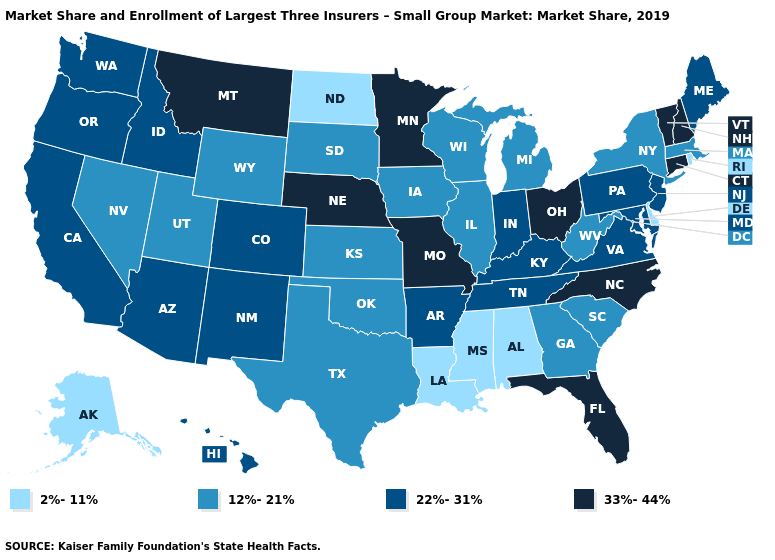Does the map have missing data?
Short answer required. No. What is the highest value in the USA?
Give a very brief answer. 33%-44%. What is the value of New York?
Keep it brief. 12%-21%. What is the value of Ohio?
Answer briefly. 33%-44%. Name the states that have a value in the range 2%-11%?
Keep it brief. Alabama, Alaska, Delaware, Louisiana, Mississippi, North Dakota, Rhode Island. Name the states that have a value in the range 33%-44%?
Answer briefly. Connecticut, Florida, Minnesota, Missouri, Montana, Nebraska, New Hampshire, North Carolina, Ohio, Vermont. What is the value of Iowa?
Give a very brief answer. 12%-21%. Does Alaska have the lowest value in the West?
Short answer required. Yes. How many symbols are there in the legend?
Short answer required. 4. Which states have the lowest value in the USA?
Quick response, please. Alabama, Alaska, Delaware, Louisiana, Mississippi, North Dakota, Rhode Island. Name the states that have a value in the range 22%-31%?
Answer briefly. Arizona, Arkansas, California, Colorado, Hawaii, Idaho, Indiana, Kentucky, Maine, Maryland, New Jersey, New Mexico, Oregon, Pennsylvania, Tennessee, Virginia, Washington. Among the states that border Oregon , which have the lowest value?
Concise answer only. Nevada. Does Missouri have the highest value in the USA?
Be succinct. Yes. What is the value of New York?
Write a very short answer. 12%-21%. How many symbols are there in the legend?
Give a very brief answer. 4. 